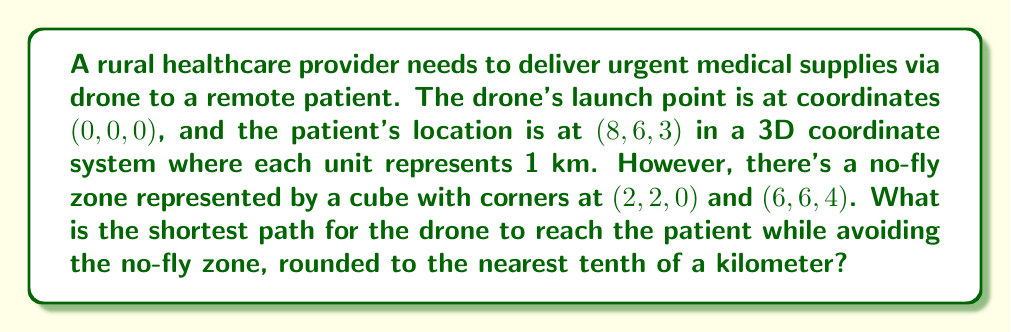Could you help me with this problem? To solve this problem, we need to find the shortest path that avoids the no-fly zone. The direct path would go through the no-fly zone, so we need to find the shortest path around it.

1) First, let's visualize the problem:

[asy]
import three;
size(200);
currentprojection=perspective(6,3,2);

// Draw axes
draw((0,0,0)--(10,0,0),arrow=Arrow3);
draw((0,0,0)--(0,10,0),arrow=Arrow3);
draw((0,0,0)--(0,0,5),arrow=Arrow3);

// Draw start and end points
dot((0,0,0),red);
dot((8,6,3),blue);

// Draw no-fly zone
draw(box((2,2,0),(6,6,4)),opacity(0.1));

// Label points
label("Start",(0,0,0),W);
label("End",(8,6,3),E);
label("No-fly zone",

[/asy]

2) The shortest path will involve going around one of the corners of the no-fly zone. We need to check all possible corners:

   (2,2,0), (2,2,4), (2,6,0), (2,6,4), (6,2,0), (6,2,4), (6,6,0), (6,6,4)

3) For each corner, we calculate the total distance:
   Distance = distance from start to corner + distance from corner to end

4) We can use the 3D distance formula:
   $$d = \sqrt{(x_2-x_1)^2 + (y_2-y_1)^2 + (z_2-z_1)^2}$$

5) Let's calculate for one corner, (2,2,4):
   Start to corner: $\sqrt{2^2 + 2^2 + 4^2} = \sqrt{24} = 4.90$ km
   Corner to end: $\sqrt{6^2 + 4^2 + (-1)^2} = \sqrt{53} = 7.28$ km
   Total: 4.90 + 7.28 = 12.18 km

6) After calculating for all corners, we find the shortest path is through (6,6,4):
   Start to (6,6,4): $\sqrt{6^2 + 6^2 + 4^2} = \sqrt{112} = 10.58$ km
   (6,6,4) to end: $\sqrt{2^2 + 0^2 + (-1)^2} = \sqrt{5} = 2.24$ km
   Total: 10.58 + 2.24 = 12.82 km

7) Rounding to the nearest tenth: 12.8 km
Answer: The shortest path for the drone to reach the patient while avoiding the no-fly zone is approximately 12.8 km. 